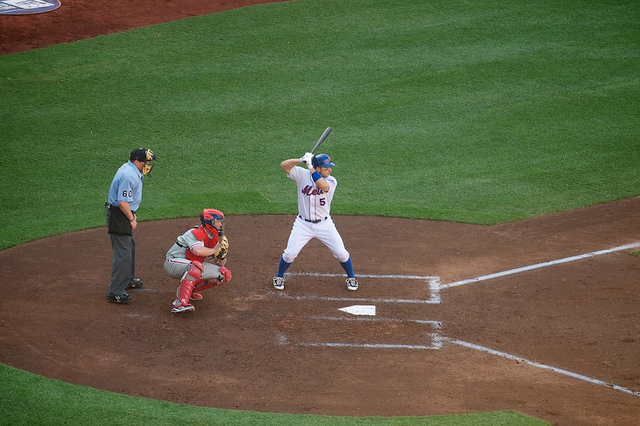Please identify all text content in this image. 60 5 Mel 